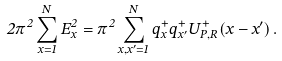<formula> <loc_0><loc_0><loc_500><loc_500>2 \pi ^ { 2 } \sum _ { x = 1 } ^ { N } E _ { x } ^ { 2 } = \pi ^ { 2 } \sum _ { x , x ^ { \prime } = 1 } ^ { N } q _ { x } ^ { + } q _ { x ^ { \prime } } ^ { + } U _ { P , R } ^ { + } ( x - x ^ { \prime } ) \, .</formula> 